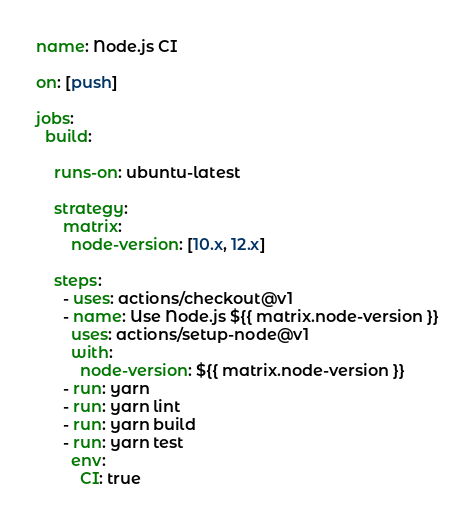<code> <loc_0><loc_0><loc_500><loc_500><_YAML_>name: Node.js CI

on: [push]

jobs:
  build:

    runs-on: ubuntu-latest

    strategy:
      matrix:
        node-version: [10.x, 12.x]

    steps:
      - uses: actions/checkout@v1
      - name: Use Node.js ${{ matrix.node-version }}
        uses: actions/setup-node@v1
        with:
          node-version: ${{ matrix.node-version }}
      - run: yarn
      - run: yarn lint
      - run: yarn build
      - run: yarn test
        env:
          CI: true
</code> 